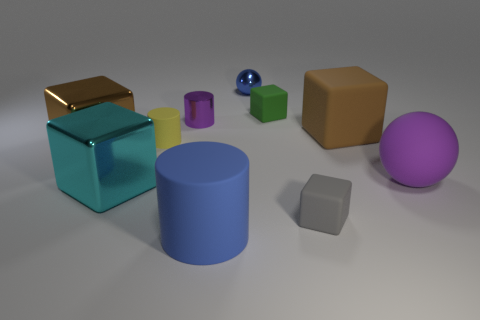What number of objects are blue matte cylinders or tiny cylinders?
Offer a terse response. 3. What is the shape of the small thing that is the same color as the big matte sphere?
Give a very brief answer. Cylinder. There is a matte block that is both behind the big purple thing and to the right of the tiny green object; what size is it?
Keep it short and to the point. Large. How many gray metal cubes are there?
Ensure brevity in your answer.  0. What number of cylinders are brown rubber objects or purple rubber objects?
Your answer should be compact. 0. There is a brown object on the left side of the small shiny object that is to the left of the blue matte cylinder; what number of brown cubes are on the right side of it?
Your response must be concise. 1. What color is the rubber cylinder that is the same size as the brown shiny cube?
Provide a short and direct response. Blue. How many other things are the same color as the large matte cylinder?
Your response must be concise. 1. Is the number of tiny blue shiny things on the left side of the brown rubber thing greater than the number of large yellow blocks?
Ensure brevity in your answer.  Yes. Are the tiny yellow cylinder and the tiny gray block made of the same material?
Make the answer very short. Yes. 